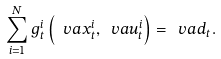<formula> <loc_0><loc_0><loc_500><loc_500>\sum _ { i = 1 } ^ { N } g _ { t } ^ { i } \left ( \ v a { x } _ { t } ^ { i } , \ v a { u } _ { t } ^ { i } \right ) = \ v a { d } _ { t } .</formula> 